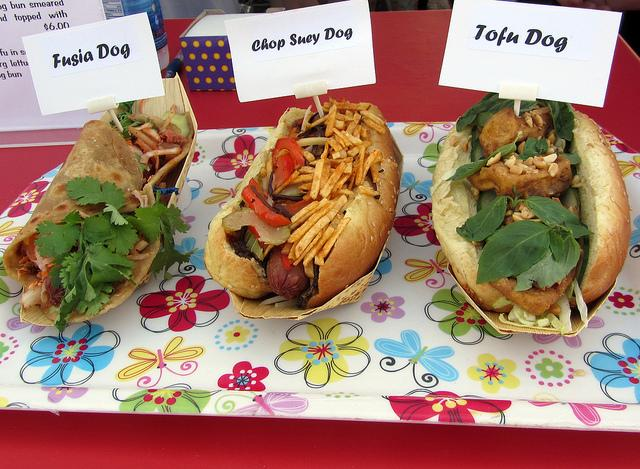What would a vegetarian order from this restaurant?

Choices:
A) monte cristo
B) hamburger
C) reuben
D) tofu dog tofu dog 